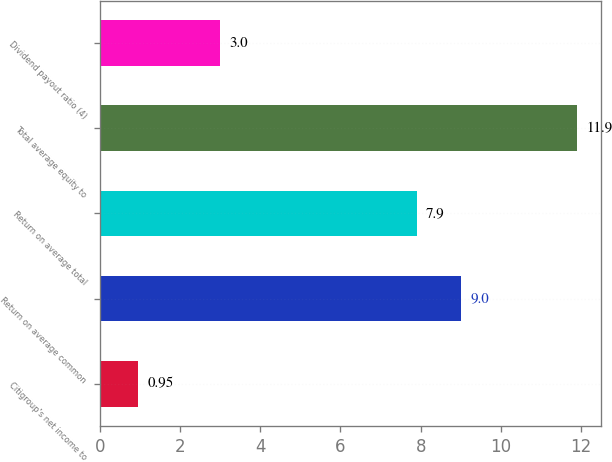<chart> <loc_0><loc_0><loc_500><loc_500><bar_chart><fcel>Citigroup's net income to<fcel>Return on average common<fcel>Return on average total<fcel>Total average equity to<fcel>Dividend payout ratio (4)<nl><fcel>0.95<fcel>9<fcel>7.9<fcel>11.9<fcel>3<nl></chart> 